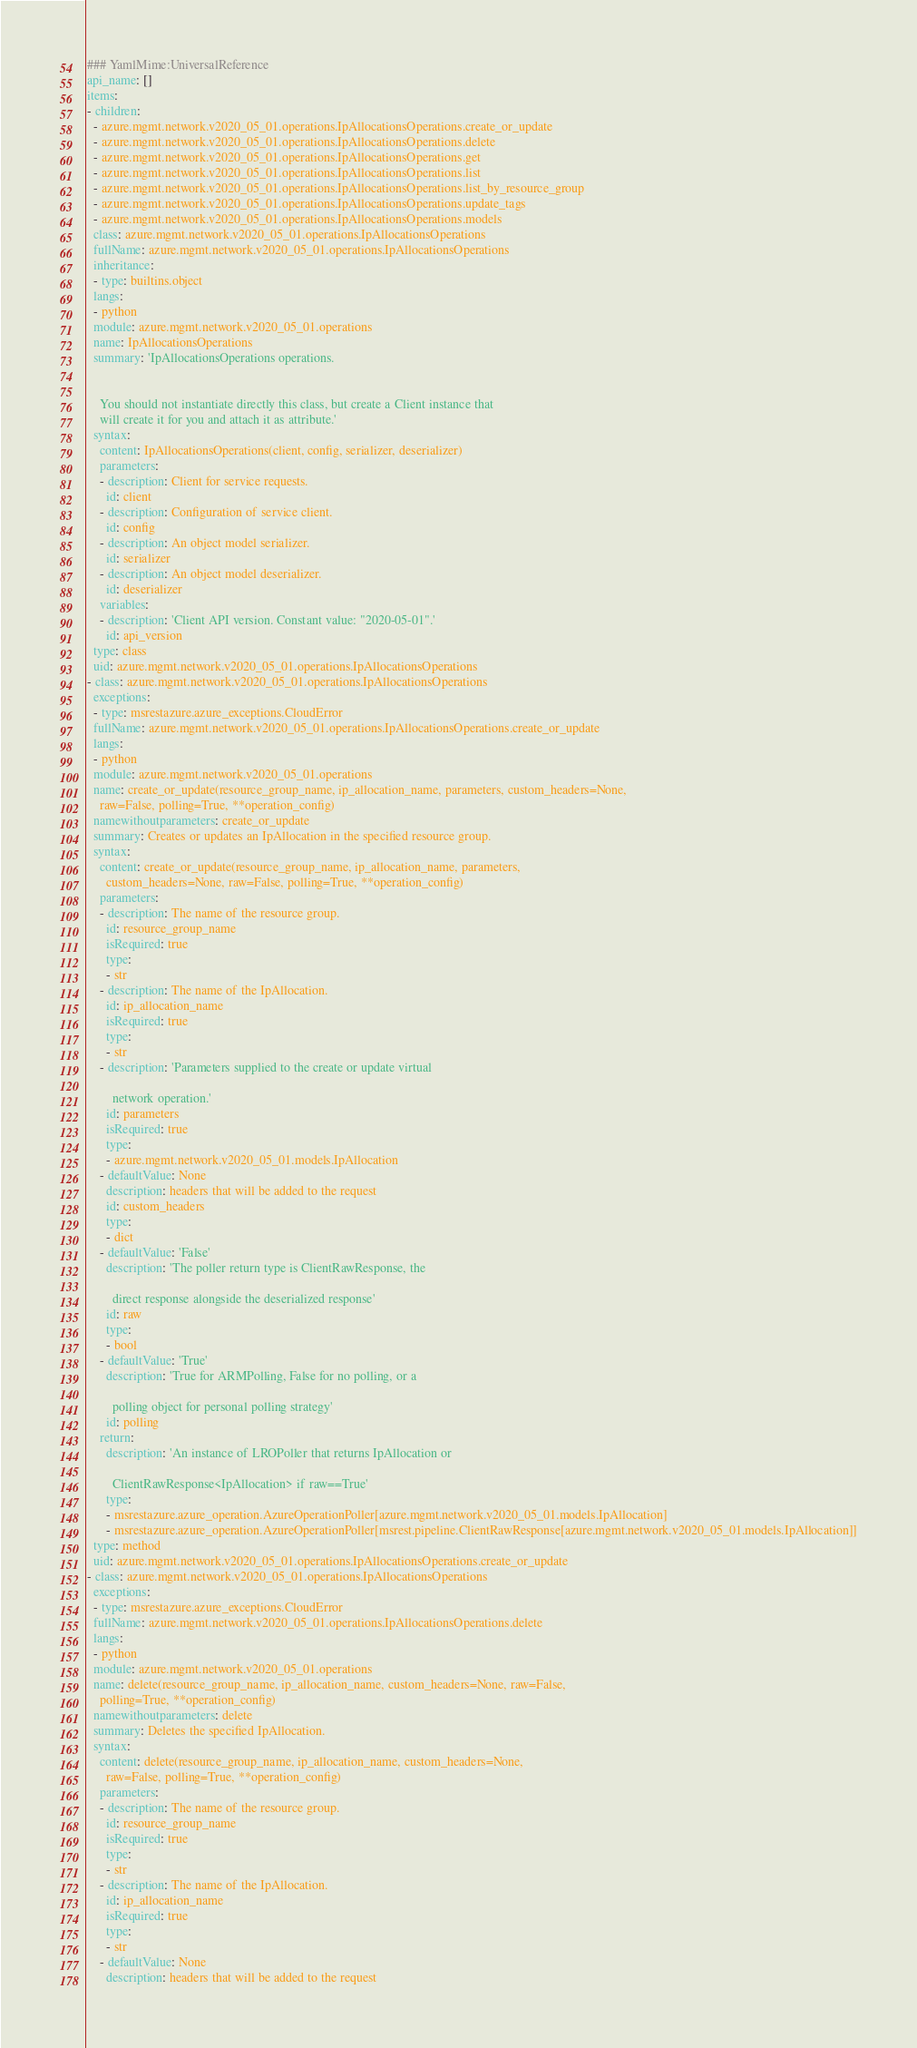Convert code to text. <code><loc_0><loc_0><loc_500><loc_500><_YAML_>### YamlMime:UniversalReference
api_name: []
items:
- children:
  - azure.mgmt.network.v2020_05_01.operations.IpAllocationsOperations.create_or_update
  - azure.mgmt.network.v2020_05_01.operations.IpAllocationsOperations.delete
  - azure.mgmt.network.v2020_05_01.operations.IpAllocationsOperations.get
  - azure.mgmt.network.v2020_05_01.operations.IpAllocationsOperations.list
  - azure.mgmt.network.v2020_05_01.operations.IpAllocationsOperations.list_by_resource_group
  - azure.mgmt.network.v2020_05_01.operations.IpAllocationsOperations.update_tags
  - azure.mgmt.network.v2020_05_01.operations.IpAllocationsOperations.models
  class: azure.mgmt.network.v2020_05_01.operations.IpAllocationsOperations
  fullName: azure.mgmt.network.v2020_05_01.operations.IpAllocationsOperations
  inheritance:
  - type: builtins.object
  langs:
  - python
  module: azure.mgmt.network.v2020_05_01.operations
  name: IpAllocationsOperations
  summary: 'IpAllocationsOperations operations.


    You should not instantiate directly this class, but create a Client instance that
    will create it for you and attach it as attribute.'
  syntax:
    content: IpAllocationsOperations(client, config, serializer, deserializer)
    parameters:
    - description: Client for service requests.
      id: client
    - description: Configuration of service client.
      id: config
    - description: An object model serializer.
      id: serializer
    - description: An object model deserializer.
      id: deserializer
    variables:
    - description: 'Client API version. Constant value: "2020-05-01".'
      id: api_version
  type: class
  uid: azure.mgmt.network.v2020_05_01.operations.IpAllocationsOperations
- class: azure.mgmt.network.v2020_05_01.operations.IpAllocationsOperations
  exceptions:
  - type: msrestazure.azure_exceptions.CloudError
  fullName: azure.mgmt.network.v2020_05_01.operations.IpAllocationsOperations.create_or_update
  langs:
  - python
  module: azure.mgmt.network.v2020_05_01.operations
  name: create_or_update(resource_group_name, ip_allocation_name, parameters, custom_headers=None,
    raw=False, polling=True, **operation_config)
  namewithoutparameters: create_or_update
  summary: Creates or updates an IpAllocation in the specified resource group.
  syntax:
    content: create_or_update(resource_group_name, ip_allocation_name, parameters,
      custom_headers=None, raw=False, polling=True, **operation_config)
    parameters:
    - description: The name of the resource group.
      id: resource_group_name
      isRequired: true
      type:
      - str
    - description: The name of the IpAllocation.
      id: ip_allocation_name
      isRequired: true
      type:
      - str
    - description: 'Parameters supplied to the create or update virtual

        network operation.'
      id: parameters
      isRequired: true
      type:
      - azure.mgmt.network.v2020_05_01.models.IpAllocation
    - defaultValue: None
      description: headers that will be added to the request
      id: custom_headers
      type:
      - dict
    - defaultValue: 'False'
      description: 'The poller return type is ClientRawResponse, the

        direct response alongside the deserialized response'
      id: raw
      type:
      - bool
    - defaultValue: 'True'
      description: 'True for ARMPolling, False for no polling, or a

        polling object for personal polling strategy'
      id: polling
    return:
      description: 'An instance of LROPoller that returns IpAllocation or

        ClientRawResponse<IpAllocation> if raw==True'
      type:
      - msrestazure.azure_operation.AzureOperationPoller[azure.mgmt.network.v2020_05_01.models.IpAllocation]
      - msrestazure.azure_operation.AzureOperationPoller[msrest.pipeline.ClientRawResponse[azure.mgmt.network.v2020_05_01.models.IpAllocation]]
  type: method
  uid: azure.mgmt.network.v2020_05_01.operations.IpAllocationsOperations.create_or_update
- class: azure.mgmt.network.v2020_05_01.operations.IpAllocationsOperations
  exceptions:
  - type: msrestazure.azure_exceptions.CloudError
  fullName: azure.mgmt.network.v2020_05_01.operations.IpAllocationsOperations.delete
  langs:
  - python
  module: azure.mgmt.network.v2020_05_01.operations
  name: delete(resource_group_name, ip_allocation_name, custom_headers=None, raw=False,
    polling=True, **operation_config)
  namewithoutparameters: delete
  summary: Deletes the specified IpAllocation.
  syntax:
    content: delete(resource_group_name, ip_allocation_name, custom_headers=None,
      raw=False, polling=True, **operation_config)
    parameters:
    - description: The name of the resource group.
      id: resource_group_name
      isRequired: true
      type:
      - str
    - description: The name of the IpAllocation.
      id: ip_allocation_name
      isRequired: true
      type:
      - str
    - defaultValue: None
      description: headers that will be added to the request</code> 